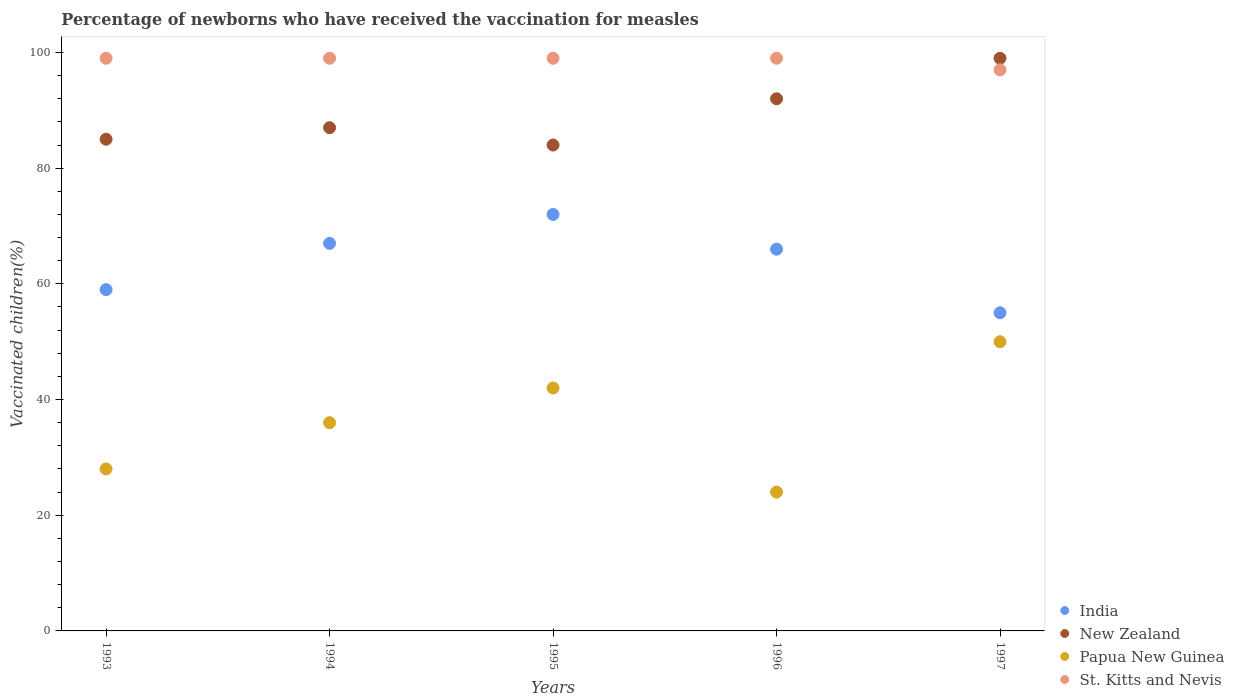How many different coloured dotlines are there?
Offer a very short reply. 4. Is the number of dotlines equal to the number of legend labels?
Give a very brief answer. Yes. What is the percentage of vaccinated children in St. Kitts and Nevis in 1996?
Your answer should be compact. 99. Across all years, what is the minimum percentage of vaccinated children in Papua New Guinea?
Provide a succinct answer. 24. In which year was the percentage of vaccinated children in St. Kitts and Nevis minimum?
Offer a terse response. 1997. What is the total percentage of vaccinated children in St. Kitts and Nevis in the graph?
Your response must be concise. 493. What is the difference between the percentage of vaccinated children in New Zealand in 1993 and the percentage of vaccinated children in St. Kitts and Nevis in 1996?
Your answer should be very brief. -14. What is the average percentage of vaccinated children in India per year?
Your answer should be very brief. 63.8. In the year 1997, what is the difference between the percentage of vaccinated children in India and percentage of vaccinated children in St. Kitts and Nevis?
Offer a terse response. -42. What is the ratio of the percentage of vaccinated children in New Zealand in 1994 to that in 1995?
Keep it short and to the point. 1.04. Is the difference between the percentage of vaccinated children in India in 1996 and 1997 greater than the difference between the percentage of vaccinated children in St. Kitts and Nevis in 1996 and 1997?
Keep it short and to the point. Yes. What is the difference between the highest and the second highest percentage of vaccinated children in New Zealand?
Make the answer very short. 7. In how many years, is the percentage of vaccinated children in India greater than the average percentage of vaccinated children in India taken over all years?
Your answer should be very brief. 3. Is the sum of the percentage of vaccinated children in India in 1995 and 1996 greater than the maximum percentage of vaccinated children in New Zealand across all years?
Offer a very short reply. Yes. Is it the case that in every year, the sum of the percentage of vaccinated children in Papua New Guinea and percentage of vaccinated children in India  is greater than the sum of percentage of vaccinated children in St. Kitts and Nevis and percentage of vaccinated children in New Zealand?
Keep it short and to the point. No. Is it the case that in every year, the sum of the percentage of vaccinated children in India and percentage of vaccinated children in St. Kitts and Nevis  is greater than the percentage of vaccinated children in Papua New Guinea?
Give a very brief answer. Yes. Does the percentage of vaccinated children in New Zealand monotonically increase over the years?
Give a very brief answer. No. Is the percentage of vaccinated children in New Zealand strictly greater than the percentage of vaccinated children in India over the years?
Offer a terse response. Yes. Is the percentage of vaccinated children in India strictly less than the percentage of vaccinated children in St. Kitts and Nevis over the years?
Your answer should be compact. Yes. How many dotlines are there?
Make the answer very short. 4. What is the difference between two consecutive major ticks on the Y-axis?
Your response must be concise. 20. Does the graph contain grids?
Your response must be concise. No. Where does the legend appear in the graph?
Provide a succinct answer. Bottom right. How are the legend labels stacked?
Make the answer very short. Vertical. What is the title of the graph?
Make the answer very short. Percentage of newborns who have received the vaccination for measles. Does "Dominican Republic" appear as one of the legend labels in the graph?
Offer a terse response. No. What is the label or title of the Y-axis?
Make the answer very short. Vaccinated children(%). What is the Vaccinated children(%) of India in 1993?
Your answer should be very brief. 59. What is the Vaccinated children(%) in Papua New Guinea in 1993?
Your answer should be very brief. 28. What is the Vaccinated children(%) of St. Kitts and Nevis in 1993?
Ensure brevity in your answer.  99. What is the Vaccinated children(%) of India in 1994?
Make the answer very short. 67. What is the Vaccinated children(%) in New Zealand in 1994?
Give a very brief answer. 87. What is the Vaccinated children(%) of St. Kitts and Nevis in 1994?
Ensure brevity in your answer.  99. What is the Vaccinated children(%) in India in 1995?
Give a very brief answer. 72. What is the Vaccinated children(%) in New Zealand in 1995?
Your answer should be compact. 84. What is the Vaccinated children(%) of New Zealand in 1996?
Keep it short and to the point. 92. What is the Vaccinated children(%) in New Zealand in 1997?
Offer a terse response. 99. What is the Vaccinated children(%) in Papua New Guinea in 1997?
Your answer should be very brief. 50. What is the Vaccinated children(%) of St. Kitts and Nevis in 1997?
Provide a short and direct response. 97. Across all years, what is the maximum Vaccinated children(%) of New Zealand?
Give a very brief answer. 99. Across all years, what is the maximum Vaccinated children(%) in Papua New Guinea?
Your answer should be very brief. 50. Across all years, what is the minimum Vaccinated children(%) in St. Kitts and Nevis?
Give a very brief answer. 97. What is the total Vaccinated children(%) of India in the graph?
Give a very brief answer. 319. What is the total Vaccinated children(%) in New Zealand in the graph?
Ensure brevity in your answer.  447. What is the total Vaccinated children(%) in Papua New Guinea in the graph?
Provide a short and direct response. 180. What is the total Vaccinated children(%) in St. Kitts and Nevis in the graph?
Keep it short and to the point. 493. What is the difference between the Vaccinated children(%) of India in 1993 and that in 1994?
Your response must be concise. -8. What is the difference between the Vaccinated children(%) in Papua New Guinea in 1993 and that in 1994?
Make the answer very short. -8. What is the difference between the Vaccinated children(%) of St. Kitts and Nevis in 1993 and that in 1994?
Offer a very short reply. 0. What is the difference between the Vaccinated children(%) in India in 1993 and that in 1995?
Offer a terse response. -13. What is the difference between the Vaccinated children(%) in St. Kitts and Nevis in 1993 and that in 1995?
Give a very brief answer. 0. What is the difference between the Vaccinated children(%) of India in 1993 and that in 1996?
Provide a short and direct response. -7. What is the difference between the Vaccinated children(%) of Papua New Guinea in 1993 and that in 1996?
Your answer should be very brief. 4. What is the difference between the Vaccinated children(%) in St. Kitts and Nevis in 1993 and that in 1996?
Offer a terse response. 0. What is the difference between the Vaccinated children(%) in New Zealand in 1993 and that in 1997?
Your response must be concise. -14. What is the difference between the Vaccinated children(%) in India in 1994 and that in 1995?
Provide a succinct answer. -5. What is the difference between the Vaccinated children(%) of Papua New Guinea in 1994 and that in 1995?
Keep it short and to the point. -6. What is the difference between the Vaccinated children(%) of St. Kitts and Nevis in 1994 and that in 1995?
Your response must be concise. 0. What is the difference between the Vaccinated children(%) of New Zealand in 1994 and that in 1997?
Your answer should be very brief. -12. What is the difference between the Vaccinated children(%) in Papua New Guinea in 1994 and that in 1997?
Your response must be concise. -14. What is the difference between the Vaccinated children(%) of St. Kitts and Nevis in 1994 and that in 1997?
Give a very brief answer. 2. What is the difference between the Vaccinated children(%) of India in 1995 and that in 1996?
Keep it short and to the point. 6. What is the difference between the Vaccinated children(%) of New Zealand in 1995 and that in 1996?
Give a very brief answer. -8. What is the difference between the Vaccinated children(%) in St. Kitts and Nevis in 1995 and that in 1996?
Give a very brief answer. 0. What is the difference between the Vaccinated children(%) in Papua New Guinea in 1995 and that in 1997?
Your response must be concise. -8. What is the difference between the Vaccinated children(%) of India in 1996 and that in 1997?
Give a very brief answer. 11. What is the difference between the Vaccinated children(%) of Papua New Guinea in 1996 and that in 1997?
Your response must be concise. -26. What is the difference between the Vaccinated children(%) of India in 1993 and the Vaccinated children(%) of New Zealand in 1994?
Your answer should be very brief. -28. What is the difference between the Vaccinated children(%) in India in 1993 and the Vaccinated children(%) in St. Kitts and Nevis in 1994?
Your response must be concise. -40. What is the difference between the Vaccinated children(%) of New Zealand in 1993 and the Vaccinated children(%) of Papua New Guinea in 1994?
Provide a succinct answer. 49. What is the difference between the Vaccinated children(%) in New Zealand in 1993 and the Vaccinated children(%) in St. Kitts and Nevis in 1994?
Give a very brief answer. -14. What is the difference between the Vaccinated children(%) of Papua New Guinea in 1993 and the Vaccinated children(%) of St. Kitts and Nevis in 1994?
Offer a terse response. -71. What is the difference between the Vaccinated children(%) in India in 1993 and the Vaccinated children(%) in New Zealand in 1995?
Keep it short and to the point. -25. What is the difference between the Vaccinated children(%) of India in 1993 and the Vaccinated children(%) of Papua New Guinea in 1995?
Give a very brief answer. 17. What is the difference between the Vaccinated children(%) of India in 1993 and the Vaccinated children(%) of St. Kitts and Nevis in 1995?
Your answer should be very brief. -40. What is the difference between the Vaccinated children(%) in New Zealand in 1993 and the Vaccinated children(%) in Papua New Guinea in 1995?
Offer a terse response. 43. What is the difference between the Vaccinated children(%) of New Zealand in 1993 and the Vaccinated children(%) of St. Kitts and Nevis in 1995?
Provide a succinct answer. -14. What is the difference between the Vaccinated children(%) of Papua New Guinea in 1993 and the Vaccinated children(%) of St. Kitts and Nevis in 1995?
Provide a succinct answer. -71. What is the difference between the Vaccinated children(%) of India in 1993 and the Vaccinated children(%) of New Zealand in 1996?
Offer a very short reply. -33. What is the difference between the Vaccinated children(%) of India in 1993 and the Vaccinated children(%) of St. Kitts and Nevis in 1996?
Provide a succinct answer. -40. What is the difference between the Vaccinated children(%) of New Zealand in 1993 and the Vaccinated children(%) of Papua New Guinea in 1996?
Provide a short and direct response. 61. What is the difference between the Vaccinated children(%) in New Zealand in 1993 and the Vaccinated children(%) in St. Kitts and Nevis in 1996?
Your response must be concise. -14. What is the difference between the Vaccinated children(%) in Papua New Guinea in 1993 and the Vaccinated children(%) in St. Kitts and Nevis in 1996?
Make the answer very short. -71. What is the difference between the Vaccinated children(%) in India in 1993 and the Vaccinated children(%) in New Zealand in 1997?
Offer a terse response. -40. What is the difference between the Vaccinated children(%) of India in 1993 and the Vaccinated children(%) of Papua New Guinea in 1997?
Your answer should be very brief. 9. What is the difference between the Vaccinated children(%) in India in 1993 and the Vaccinated children(%) in St. Kitts and Nevis in 1997?
Your answer should be very brief. -38. What is the difference between the Vaccinated children(%) of New Zealand in 1993 and the Vaccinated children(%) of Papua New Guinea in 1997?
Your answer should be very brief. 35. What is the difference between the Vaccinated children(%) in Papua New Guinea in 1993 and the Vaccinated children(%) in St. Kitts and Nevis in 1997?
Provide a succinct answer. -69. What is the difference between the Vaccinated children(%) of India in 1994 and the Vaccinated children(%) of St. Kitts and Nevis in 1995?
Give a very brief answer. -32. What is the difference between the Vaccinated children(%) in Papua New Guinea in 1994 and the Vaccinated children(%) in St. Kitts and Nevis in 1995?
Keep it short and to the point. -63. What is the difference between the Vaccinated children(%) in India in 1994 and the Vaccinated children(%) in Papua New Guinea in 1996?
Ensure brevity in your answer.  43. What is the difference between the Vaccinated children(%) in India in 1994 and the Vaccinated children(%) in St. Kitts and Nevis in 1996?
Ensure brevity in your answer.  -32. What is the difference between the Vaccinated children(%) in Papua New Guinea in 1994 and the Vaccinated children(%) in St. Kitts and Nevis in 1996?
Your answer should be very brief. -63. What is the difference between the Vaccinated children(%) in India in 1994 and the Vaccinated children(%) in New Zealand in 1997?
Provide a succinct answer. -32. What is the difference between the Vaccinated children(%) in Papua New Guinea in 1994 and the Vaccinated children(%) in St. Kitts and Nevis in 1997?
Keep it short and to the point. -61. What is the difference between the Vaccinated children(%) in India in 1995 and the Vaccinated children(%) in New Zealand in 1996?
Make the answer very short. -20. What is the difference between the Vaccinated children(%) of India in 1995 and the Vaccinated children(%) of St. Kitts and Nevis in 1996?
Make the answer very short. -27. What is the difference between the Vaccinated children(%) in Papua New Guinea in 1995 and the Vaccinated children(%) in St. Kitts and Nevis in 1996?
Your answer should be compact. -57. What is the difference between the Vaccinated children(%) in India in 1995 and the Vaccinated children(%) in St. Kitts and Nevis in 1997?
Make the answer very short. -25. What is the difference between the Vaccinated children(%) of New Zealand in 1995 and the Vaccinated children(%) of St. Kitts and Nevis in 1997?
Your answer should be compact. -13. What is the difference between the Vaccinated children(%) of Papua New Guinea in 1995 and the Vaccinated children(%) of St. Kitts and Nevis in 1997?
Ensure brevity in your answer.  -55. What is the difference between the Vaccinated children(%) in India in 1996 and the Vaccinated children(%) in New Zealand in 1997?
Offer a terse response. -33. What is the difference between the Vaccinated children(%) of India in 1996 and the Vaccinated children(%) of Papua New Guinea in 1997?
Offer a very short reply. 16. What is the difference between the Vaccinated children(%) of India in 1996 and the Vaccinated children(%) of St. Kitts and Nevis in 1997?
Your response must be concise. -31. What is the difference between the Vaccinated children(%) of New Zealand in 1996 and the Vaccinated children(%) of St. Kitts and Nevis in 1997?
Keep it short and to the point. -5. What is the difference between the Vaccinated children(%) in Papua New Guinea in 1996 and the Vaccinated children(%) in St. Kitts and Nevis in 1997?
Ensure brevity in your answer.  -73. What is the average Vaccinated children(%) in India per year?
Provide a short and direct response. 63.8. What is the average Vaccinated children(%) of New Zealand per year?
Offer a terse response. 89.4. What is the average Vaccinated children(%) in Papua New Guinea per year?
Your answer should be very brief. 36. What is the average Vaccinated children(%) in St. Kitts and Nevis per year?
Your response must be concise. 98.6. In the year 1993, what is the difference between the Vaccinated children(%) of India and Vaccinated children(%) of St. Kitts and Nevis?
Give a very brief answer. -40. In the year 1993, what is the difference between the Vaccinated children(%) in New Zealand and Vaccinated children(%) in St. Kitts and Nevis?
Make the answer very short. -14. In the year 1993, what is the difference between the Vaccinated children(%) in Papua New Guinea and Vaccinated children(%) in St. Kitts and Nevis?
Your answer should be very brief. -71. In the year 1994, what is the difference between the Vaccinated children(%) of India and Vaccinated children(%) of St. Kitts and Nevis?
Ensure brevity in your answer.  -32. In the year 1994, what is the difference between the Vaccinated children(%) in Papua New Guinea and Vaccinated children(%) in St. Kitts and Nevis?
Make the answer very short. -63. In the year 1995, what is the difference between the Vaccinated children(%) in India and Vaccinated children(%) in New Zealand?
Your answer should be very brief. -12. In the year 1995, what is the difference between the Vaccinated children(%) of India and Vaccinated children(%) of Papua New Guinea?
Your response must be concise. 30. In the year 1995, what is the difference between the Vaccinated children(%) of New Zealand and Vaccinated children(%) of Papua New Guinea?
Provide a succinct answer. 42. In the year 1995, what is the difference between the Vaccinated children(%) of New Zealand and Vaccinated children(%) of St. Kitts and Nevis?
Your answer should be very brief. -15. In the year 1995, what is the difference between the Vaccinated children(%) in Papua New Guinea and Vaccinated children(%) in St. Kitts and Nevis?
Keep it short and to the point. -57. In the year 1996, what is the difference between the Vaccinated children(%) of India and Vaccinated children(%) of Papua New Guinea?
Your answer should be very brief. 42. In the year 1996, what is the difference between the Vaccinated children(%) of India and Vaccinated children(%) of St. Kitts and Nevis?
Your answer should be compact. -33. In the year 1996, what is the difference between the Vaccinated children(%) of New Zealand and Vaccinated children(%) of Papua New Guinea?
Provide a succinct answer. 68. In the year 1996, what is the difference between the Vaccinated children(%) in Papua New Guinea and Vaccinated children(%) in St. Kitts and Nevis?
Your response must be concise. -75. In the year 1997, what is the difference between the Vaccinated children(%) in India and Vaccinated children(%) in New Zealand?
Your response must be concise. -44. In the year 1997, what is the difference between the Vaccinated children(%) in India and Vaccinated children(%) in St. Kitts and Nevis?
Provide a succinct answer. -42. In the year 1997, what is the difference between the Vaccinated children(%) in Papua New Guinea and Vaccinated children(%) in St. Kitts and Nevis?
Offer a terse response. -47. What is the ratio of the Vaccinated children(%) of India in 1993 to that in 1994?
Offer a terse response. 0.88. What is the ratio of the Vaccinated children(%) of Papua New Guinea in 1993 to that in 1994?
Give a very brief answer. 0.78. What is the ratio of the Vaccinated children(%) in St. Kitts and Nevis in 1993 to that in 1994?
Your response must be concise. 1. What is the ratio of the Vaccinated children(%) of India in 1993 to that in 1995?
Your answer should be very brief. 0.82. What is the ratio of the Vaccinated children(%) of New Zealand in 1993 to that in 1995?
Make the answer very short. 1.01. What is the ratio of the Vaccinated children(%) in Papua New Guinea in 1993 to that in 1995?
Your answer should be compact. 0.67. What is the ratio of the Vaccinated children(%) in India in 1993 to that in 1996?
Make the answer very short. 0.89. What is the ratio of the Vaccinated children(%) in New Zealand in 1993 to that in 1996?
Make the answer very short. 0.92. What is the ratio of the Vaccinated children(%) in India in 1993 to that in 1997?
Provide a short and direct response. 1.07. What is the ratio of the Vaccinated children(%) in New Zealand in 1993 to that in 1997?
Keep it short and to the point. 0.86. What is the ratio of the Vaccinated children(%) of Papua New Guinea in 1993 to that in 1997?
Ensure brevity in your answer.  0.56. What is the ratio of the Vaccinated children(%) of St. Kitts and Nevis in 1993 to that in 1997?
Provide a short and direct response. 1.02. What is the ratio of the Vaccinated children(%) in India in 1994 to that in 1995?
Keep it short and to the point. 0.93. What is the ratio of the Vaccinated children(%) of New Zealand in 1994 to that in 1995?
Offer a very short reply. 1.04. What is the ratio of the Vaccinated children(%) in St. Kitts and Nevis in 1994 to that in 1995?
Offer a terse response. 1. What is the ratio of the Vaccinated children(%) of India in 1994 to that in 1996?
Provide a succinct answer. 1.02. What is the ratio of the Vaccinated children(%) of New Zealand in 1994 to that in 1996?
Provide a succinct answer. 0.95. What is the ratio of the Vaccinated children(%) of St. Kitts and Nevis in 1994 to that in 1996?
Provide a short and direct response. 1. What is the ratio of the Vaccinated children(%) of India in 1994 to that in 1997?
Give a very brief answer. 1.22. What is the ratio of the Vaccinated children(%) in New Zealand in 1994 to that in 1997?
Make the answer very short. 0.88. What is the ratio of the Vaccinated children(%) in Papua New Guinea in 1994 to that in 1997?
Offer a very short reply. 0.72. What is the ratio of the Vaccinated children(%) in St. Kitts and Nevis in 1994 to that in 1997?
Offer a very short reply. 1.02. What is the ratio of the Vaccinated children(%) of India in 1995 to that in 1996?
Your answer should be compact. 1.09. What is the ratio of the Vaccinated children(%) in Papua New Guinea in 1995 to that in 1996?
Provide a succinct answer. 1.75. What is the ratio of the Vaccinated children(%) of India in 1995 to that in 1997?
Keep it short and to the point. 1.31. What is the ratio of the Vaccinated children(%) in New Zealand in 1995 to that in 1997?
Provide a short and direct response. 0.85. What is the ratio of the Vaccinated children(%) in Papua New Guinea in 1995 to that in 1997?
Ensure brevity in your answer.  0.84. What is the ratio of the Vaccinated children(%) of St. Kitts and Nevis in 1995 to that in 1997?
Offer a terse response. 1.02. What is the ratio of the Vaccinated children(%) in New Zealand in 1996 to that in 1997?
Give a very brief answer. 0.93. What is the ratio of the Vaccinated children(%) in Papua New Guinea in 1996 to that in 1997?
Provide a succinct answer. 0.48. What is the ratio of the Vaccinated children(%) in St. Kitts and Nevis in 1996 to that in 1997?
Make the answer very short. 1.02. What is the difference between the highest and the second highest Vaccinated children(%) in India?
Keep it short and to the point. 5. What is the difference between the highest and the second highest Vaccinated children(%) in New Zealand?
Provide a succinct answer. 7. What is the difference between the highest and the second highest Vaccinated children(%) of Papua New Guinea?
Provide a succinct answer. 8. What is the difference between the highest and the lowest Vaccinated children(%) in Papua New Guinea?
Make the answer very short. 26. What is the difference between the highest and the lowest Vaccinated children(%) in St. Kitts and Nevis?
Make the answer very short. 2. 